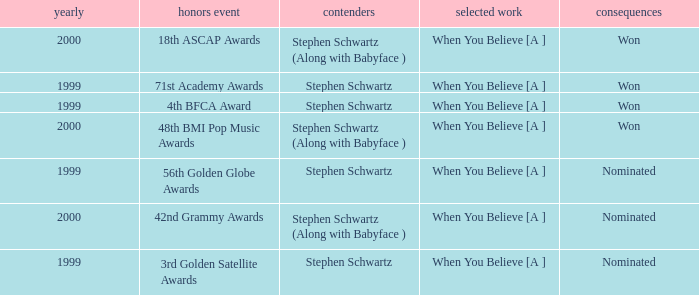What was the results of the 71st Academy Awards show? Won. 